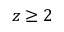Convert formula to latex. <formula><loc_0><loc_0><loc_500><loc_500>z \geq 2</formula> 